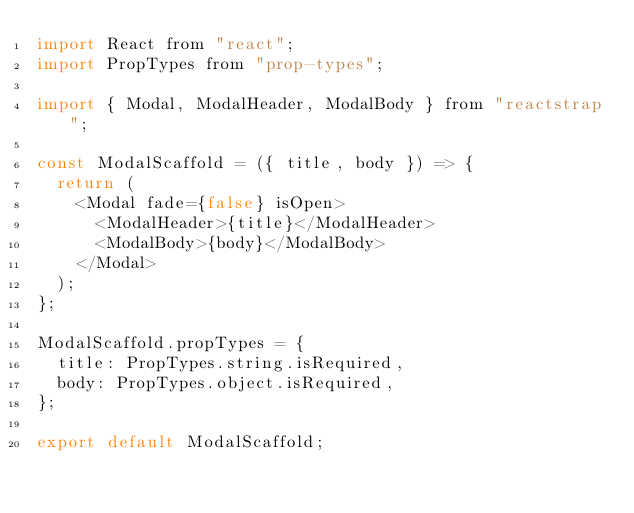<code> <loc_0><loc_0><loc_500><loc_500><_JavaScript_>import React from "react";
import PropTypes from "prop-types";

import { Modal, ModalHeader, ModalBody } from "reactstrap";

const ModalScaffold = ({ title, body }) => {
  return (
    <Modal fade={false} isOpen>
      <ModalHeader>{title}</ModalHeader>
      <ModalBody>{body}</ModalBody>
    </Modal>
  );
};

ModalScaffold.propTypes = {
  title: PropTypes.string.isRequired,
  body: PropTypes.object.isRequired,
};

export default ModalScaffold;
</code> 